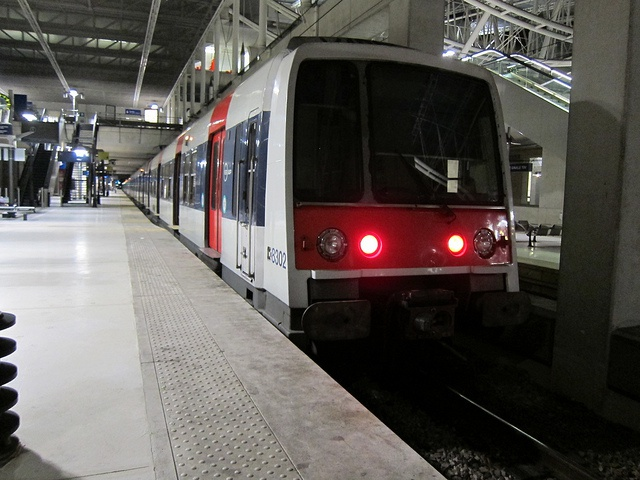Describe the objects in this image and their specific colors. I can see train in black, gray, maroon, and lightgray tones, chair in black and gray tones, chair in black and gray tones, and chair in black and gray tones in this image. 